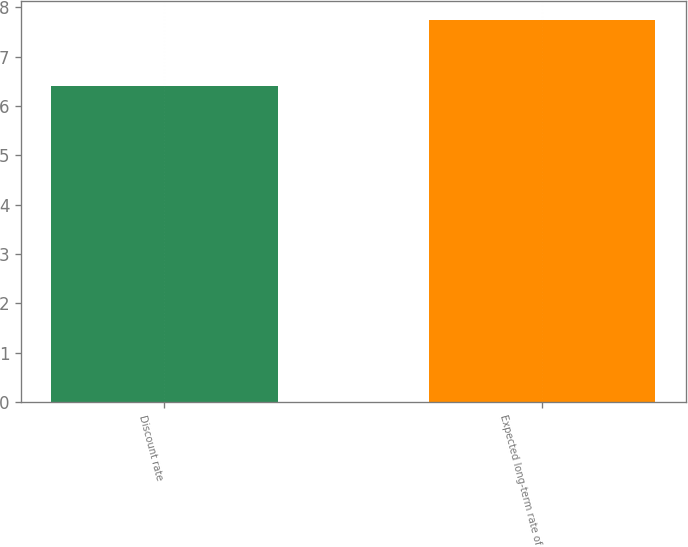Convert chart to OTSL. <chart><loc_0><loc_0><loc_500><loc_500><bar_chart><fcel>Discount rate<fcel>Expected long-term rate of<nl><fcel>6.41<fcel>7.75<nl></chart> 